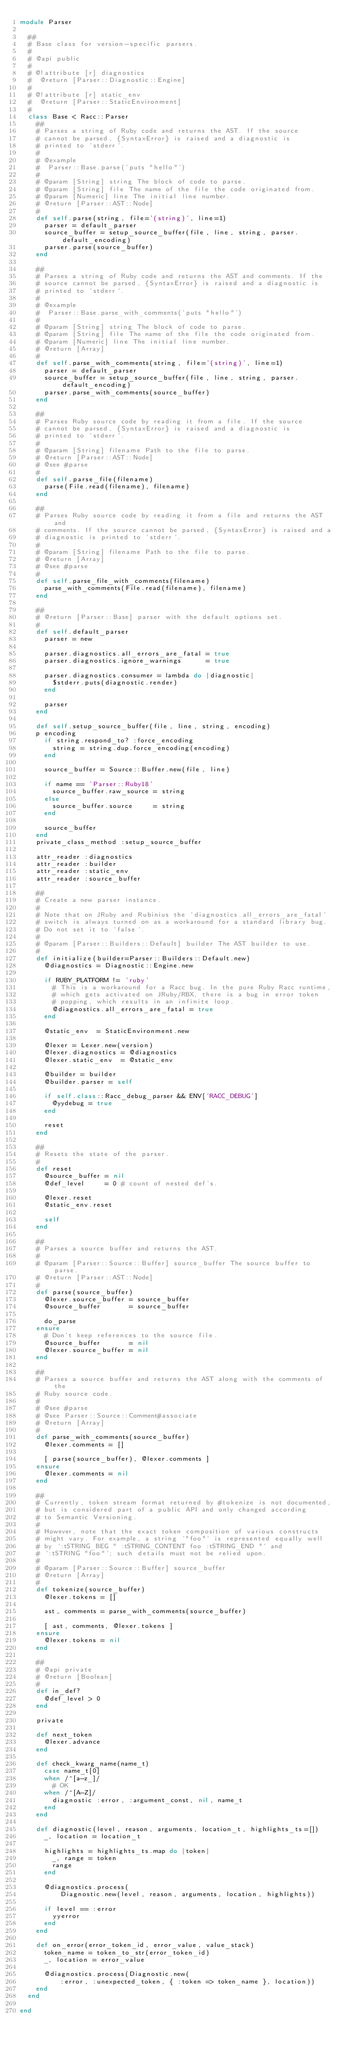<code> <loc_0><loc_0><loc_500><loc_500><_Ruby_>module Parser

  ##
  # Base class for version-specific parsers.
  #
  # @api public
  #
  # @!attribute [r] diagnostics
  #  @return [Parser::Diagnostic::Engine]
  #
  # @!attribute [r] static_env
  #  @return [Parser::StaticEnvironment]
  #
  class Base < Racc::Parser
    ##
    # Parses a string of Ruby code and returns the AST. If the source
    # cannot be parsed, {SyntaxError} is raised and a diagnostic is
    # printed to `stderr`.
    #
    # @example
    #  Parser::Base.parse('puts "hello"')
    #
    # @param [String] string The block of code to parse.
    # @param [String] file The name of the file the code originated from.
    # @param [Numeric] line The initial line number.
    # @return [Parser::AST::Node]
    #
    def self.parse(string, file='(string)', line=1)
      parser = default_parser
      source_buffer = setup_source_buffer(file, line, string, parser.default_encoding)
      parser.parse(source_buffer)
    end

    ##
    # Parses a string of Ruby code and returns the AST and comments. If the
    # source cannot be parsed, {SyntaxError} is raised and a diagnostic is
    # printed to `stderr`.
    #
    # @example
    #  Parser::Base.parse_with_comments('puts "hello"')
    #
    # @param [String] string The block of code to parse.
    # @param [String] file The name of the file the code originated from.
    # @param [Numeric] line The initial line number.
    # @return [Array]
    #
    def self.parse_with_comments(string, file='(string)', line=1)
      parser = default_parser
      source_buffer = setup_source_buffer(file, line, string, parser.default_encoding)
      parser.parse_with_comments(source_buffer)
    end

    ##
    # Parses Ruby source code by reading it from a file. If the source
    # cannot be parsed, {SyntaxError} is raised and a diagnostic is
    # printed to `stderr`.
    #
    # @param [String] filename Path to the file to parse.
    # @return [Parser::AST::Node]
    # @see #parse
    #
    def self.parse_file(filename)
      parse(File.read(filename), filename)
    end

    ##
    # Parses Ruby source code by reading it from a file and returns the AST and
    # comments. If the source cannot be parsed, {SyntaxError} is raised and a
    # diagnostic is printed to `stderr`.
    #
    # @param [String] filename Path to the file to parse.
    # @return [Array]
    # @see #parse
    #
    def self.parse_file_with_comments(filename)
      parse_with_comments(File.read(filename), filename)
    end

    ##
    # @return [Parser::Base] parser with the default options set.
    #
    def self.default_parser
      parser = new

      parser.diagnostics.all_errors_are_fatal = true
      parser.diagnostics.ignore_warnings      = true

      parser.diagnostics.consumer = lambda do |diagnostic|
        $stderr.puts(diagnostic.render)
      end

      parser
    end

    def self.setup_source_buffer(file, line, string, encoding)
    p encoding
      if string.respond_to? :force_encoding
        string = string.dup.force_encoding(encoding)
      end

      source_buffer = Source::Buffer.new(file, line)

      if name == 'Parser::Ruby18'
        source_buffer.raw_source = string
      else
        source_buffer.source     = string
      end

      source_buffer
    end
    private_class_method :setup_source_buffer

    attr_reader :diagnostics
    attr_reader :builder
    attr_reader :static_env
    attr_reader :source_buffer

    ##
    # Create a new parser instance.
    #
    # Note that on JRuby and Rubinius the `diagnostics.all_errors_are_fatal`
    # switch is always turned on as a workaround for a standard library bug.
    # Do not set it to `false`.
    #
    # @param [Parser::Builders::Default] builder The AST builder to use.
    #
    def initialize(builder=Parser::Builders::Default.new)
      @diagnostics = Diagnostic::Engine.new

      if RUBY_PLATFORM != 'ruby'
        # This is a workaround for a Racc bug. In the pure Ruby Racc runtime,
        # which gets activated on JRuby/RBX, there is a bug in error token
        # popping, which results in an infinite loop.
        @diagnostics.all_errors_are_fatal = true
      end

      @static_env  = StaticEnvironment.new

      @lexer = Lexer.new(version)
      @lexer.diagnostics = @diagnostics
      @lexer.static_env  = @static_env

      @builder = builder
      @builder.parser = self

      if self.class::Racc_debug_parser && ENV['RACC_DEBUG']
        @yydebug = true
      end

      reset
    end

    ##
    # Resets the state of the parser.
    #
    def reset
      @source_buffer = nil
      @def_level     = 0 # count of nested def's.

      @lexer.reset
      @static_env.reset

      self
    end

    ##
    # Parses a source buffer and returns the AST.
    #
    # @param [Parser::Source::Buffer] source_buffer The source buffer to parse.
    # @return [Parser::AST::Node]
    #
    def parse(source_buffer)
      @lexer.source_buffer = source_buffer
      @source_buffer       = source_buffer

      do_parse
    ensure
      # Don't keep references to the source file.
      @source_buffer       = nil
      @lexer.source_buffer = nil
    end

    ##
    # Parses a source buffer and returns the AST along with the comments of the
    # Ruby source code.
    #
    # @see #parse
    # @see Parser::Source::Comment#associate
    # @return [Array]
    #
    def parse_with_comments(source_buffer)
      @lexer.comments = []

      [ parse(source_buffer), @lexer.comments ]
    ensure
      @lexer.comments = nil
    end

    ##
    # Currently, token stream format returned by #tokenize is not documented,
    # but is considered part of a public API and only changed according
    # to Semantic Versioning.
    #
    # However, note that the exact token composition of various constructs
    # might vary. For example, a string `"foo"` is represented equally well
    # by `:tSTRING_BEG " :tSTRING_CONTENT foo :tSTRING_END "` and
    # `:tSTRING "foo"`; such details must not be relied upon.
    #
    # @param [Parser::Source::Buffer] source_buffer
    # @return [Array]
    #
    def tokenize(source_buffer)
      @lexer.tokens = []

      ast, comments = parse_with_comments(source_buffer)

      [ ast, comments, @lexer.tokens ]
    ensure
      @lexer.tokens = nil
    end

    ##
    # @api private
    # @return [Boolean]
    #
    def in_def?
      @def_level > 0
    end

    private

    def next_token
      @lexer.advance
    end

    def check_kwarg_name(name_t)
      case name_t[0]
      when /^[a-z_]/
        # OK
      when /^[A-Z]/
        diagnostic :error, :argument_const, nil, name_t
      end
    end

    def diagnostic(level, reason, arguments, location_t, highlights_ts=[])
      _, location = location_t

      highlights = highlights_ts.map do |token|
        _, range = token
        range
      end

      @diagnostics.process(
          Diagnostic.new(level, reason, arguments, location, highlights))

      if level == :error
        yyerror
      end
    end

    def on_error(error_token_id, error_value, value_stack)
      token_name = token_to_str(error_token_id)
      _, location = error_value

      @diagnostics.process(Diagnostic.new(
          :error, :unexpected_token, { :token => token_name }, location))
    end
  end

end
</code> 